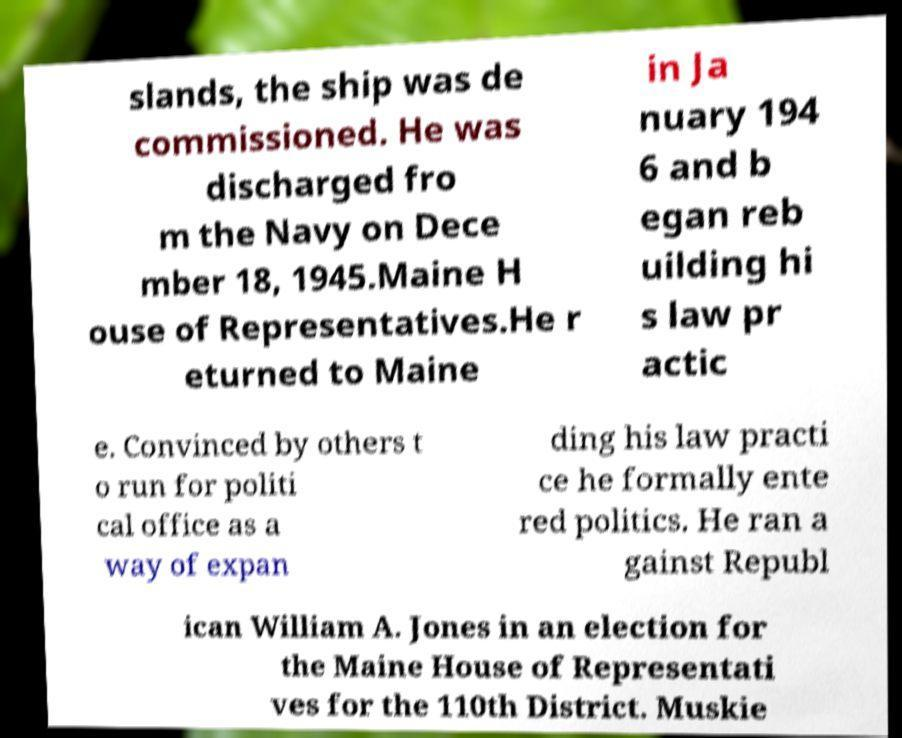I need the written content from this picture converted into text. Can you do that? slands, the ship was de commissioned. He was discharged fro m the Navy on Dece mber 18, 1945.Maine H ouse of Representatives.He r eturned to Maine in Ja nuary 194 6 and b egan reb uilding hi s law pr actic e. Convinced by others t o run for politi cal office as a way of expan ding his law practi ce he formally ente red politics. He ran a gainst Republ ican William A. Jones in an election for the Maine House of Representati ves for the 110th District. Muskie 